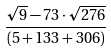Convert formula to latex. <formula><loc_0><loc_0><loc_500><loc_500>\frac { \sqrt { 9 } - 7 3 \cdot \sqrt { 2 7 6 } } { ( 5 + 1 3 3 + 3 0 6 ) }</formula> 